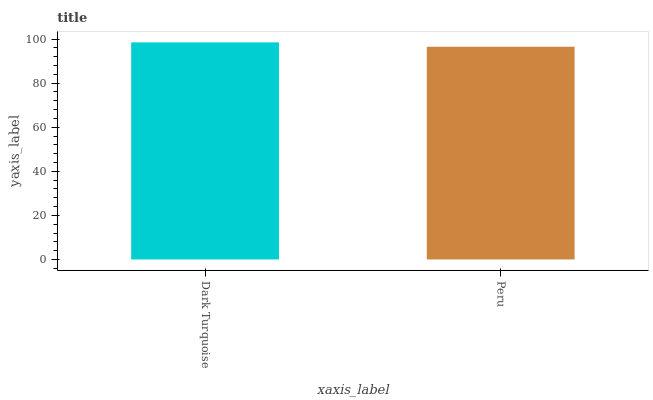Is Peru the minimum?
Answer yes or no. Yes. Is Dark Turquoise the maximum?
Answer yes or no. Yes. Is Peru the maximum?
Answer yes or no. No. Is Dark Turquoise greater than Peru?
Answer yes or no. Yes. Is Peru less than Dark Turquoise?
Answer yes or no. Yes. Is Peru greater than Dark Turquoise?
Answer yes or no. No. Is Dark Turquoise less than Peru?
Answer yes or no. No. Is Dark Turquoise the high median?
Answer yes or no. Yes. Is Peru the low median?
Answer yes or no. Yes. Is Peru the high median?
Answer yes or no. No. Is Dark Turquoise the low median?
Answer yes or no. No. 